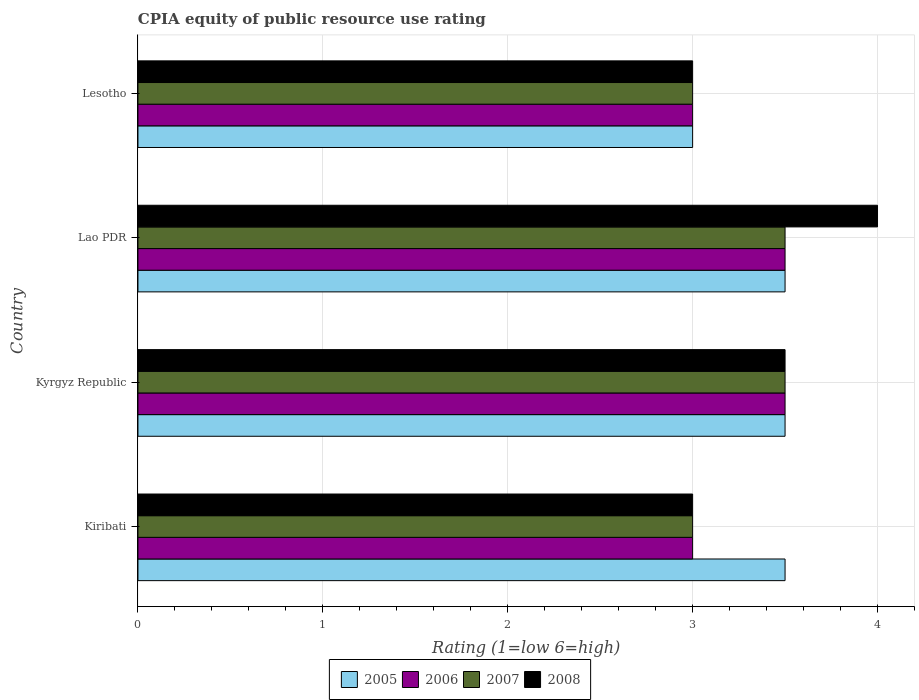How many different coloured bars are there?
Make the answer very short. 4. Are the number of bars per tick equal to the number of legend labels?
Your answer should be compact. Yes. How many bars are there on the 2nd tick from the top?
Give a very brief answer. 4. How many bars are there on the 4th tick from the bottom?
Keep it short and to the point. 4. What is the label of the 4th group of bars from the top?
Your answer should be compact. Kiribati. In how many cases, is the number of bars for a given country not equal to the number of legend labels?
Your answer should be compact. 0. What is the CPIA rating in 2005 in Lao PDR?
Provide a short and direct response. 3.5. Across all countries, what is the maximum CPIA rating in 2007?
Provide a short and direct response. 3.5. In which country was the CPIA rating in 2005 maximum?
Your response must be concise. Kiribati. In which country was the CPIA rating in 2005 minimum?
Your answer should be compact. Lesotho. What is the total CPIA rating in 2005 in the graph?
Ensure brevity in your answer.  13.5. What is the ratio of the CPIA rating in 2005 in Kyrgyz Republic to that in Lesotho?
Your answer should be compact. 1.17. What is the difference between the highest and the lowest CPIA rating in 2008?
Your answer should be compact. 1. Is the sum of the CPIA rating in 2006 in Kiribati and Kyrgyz Republic greater than the maximum CPIA rating in 2008 across all countries?
Your answer should be very brief. Yes. Is it the case that in every country, the sum of the CPIA rating in 2006 and CPIA rating in 2008 is greater than the sum of CPIA rating in 2007 and CPIA rating in 2005?
Your answer should be very brief. No. What does the 3rd bar from the bottom in Lao PDR represents?
Your response must be concise. 2007. How many bars are there?
Give a very brief answer. 16. Are all the bars in the graph horizontal?
Provide a short and direct response. Yes. What is the difference between two consecutive major ticks on the X-axis?
Your answer should be compact. 1. Are the values on the major ticks of X-axis written in scientific E-notation?
Your answer should be compact. No. Does the graph contain grids?
Give a very brief answer. Yes. How many legend labels are there?
Your answer should be very brief. 4. What is the title of the graph?
Offer a terse response. CPIA equity of public resource use rating. Does "1985" appear as one of the legend labels in the graph?
Provide a succinct answer. No. What is the label or title of the X-axis?
Ensure brevity in your answer.  Rating (1=low 6=high). What is the label or title of the Y-axis?
Offer a very short reply. Country. What is the Rating (1=low 6=high) of 2006 in Kiribati?
Your answer should be very brief. 3. What is the Rating (1=low 6=high) of 2008 in Kiribati?
Offer a terse response. 3. What is the Rating (1=low 6=high) in 2006 in Kyrgyz Republic?
Provide a short and direct response. 3.5. What is the Rating (1=low 6=high) in 2007 in Kyrgyz Republic?
Your answer should be very brief. 3.5. What is the Rating (1=low 6=high) in 2008 in Kyrgyz Republic?
Your response must be concise. 3.5. What is the Rating (1=low 6=high) of 2006 in Lao PDR?
Keep it short and to the point. 3.5. What is the Rating (1=low 6=high) of 2006 in Lesotho?
Offer a very short reply. 3. What is the Rating (1=low 6=high) in 2007 in Lesotho?
Give a very brief answer. 3. Across all countries, what is the maximum Rating (1=low 6=high) in 2007?
Your answer should be compact. 3.5. Across all countries, what is the maximum Rating (1=low 6=high) of 2008?
Make the answer very short. 4. Across all countries, what is the minimum Rating (1=low 6=high) in 2005?
Offer a terse response. 3. Across all countries, what is the minimum Rating (1=low 6=high) of 2006?
Provide a succinct answer. 3. Across all countries, what is the minimum Rating (1=low 6=high) in 2008?
Keep it short and to the point. 3. What is the total Rating (1=low 6=high) in 2005 in the graph?
Offer a very short reply. 13.5. What is the total Rating (1=low 6=high) in 2006 in the graph?
Make the answer very short. 13. What is the total Rating (1=low 6=high) in 2007 in the graph?
Offer a terse response. 13. What is the difference between the Rating (1=low 6=high) of 2005 in Kiribati and that in Kyrgyz Republic?
Give a very brief answer. 0. What is the difference between the Rating (1=low 6=high) in 2007 in Kiribati and that in Kyrgyz Republic?
Provide a short and direct response. -0.5. What is the difference between the Rating (1=low 6=high) of 2008 in Kiribati and that in Kyrgyz Republic?
Your response must be concise. -0.5. What is the difference between the Rating (1=low 6=high) of 2005 in Kiribati and that in Lao PDR?
Give a very brief answer. 0. What is the difference between the Rating (1=low 6=high) of 2006 in Kiribati and that in Lao PDR?
Provide a succinct answer. -0.5. What is the difference between the Rating (1=low 6=high) of 2007 in Kiribati and that in Lao PDR?
Offer a terse response. -0.5. What is the difference between the Rating (1=low 6=high) of 2008 in Kiribati and that in Lao PDR?
Provide a short and direct response. -1. What is the difference between the Rating (1=low 6=high) in 2005 in Kiribati and that in Lesotho?
Provide a succinct answer. 0.5. What is the difference between the Rating (1=low 6=high) of 2006 in Kiribati and that in Lesotho?
Your answer should be very brief. 0. What is the difference between the Rating (1=low 6=high) of 2007 in Kiribati and that in Lesotho?
Ensure brevity in your answer.  0. What is the difference between the Rating (1=low 6=high) of 2007 in Kyrgyz Republic and that in Lao PDR?
Ensure brevity in your answer.  0. What is the difference between the Rating (1=low 6=high) of 2005 in Kyrgyz Republic and that in Lesotho?
Your response must be concise. 0.5. What is the difference between the Rating (1=low 6=high) in 2006 in Kyrgyz Republic and that in Lesotho?
Provide a short and direct response. 0.5. What is the difference between the Rating (1=low 6=high) of 2007 in Kyrgyz Republic and that in Lesotho?
Provide a succinct answer. 0.5. What is the difference between the Rating (1=low 6=high) in 2008 in Kyrgyz Republic and that in Lesotho?
Provide a succinct answer. 0.5. What is the difference between the Rating (1=low 6=high) in 2005 in Lao PDR and that in Lesotho?
Ensure brevity in your answer.  0.5. What is the difference between the Rating (1=low 6=high) of 2008 in Lao PDR and that in Lesotho?
Provide a succinct answer. 1. What is the difference between the Rating (1=low 6=high) of 2005 in Kiribati and the Rating (1=low 6=high) of 2007 in Kyrgyz Republic?
Offer a terse response. 0. What is the difference between the Rating (1=low 6=high) of 2006 in Kiribati and the Rating (1=low 6=high) of 2007 in Kyrgyz Republic?
Offer a terse response. -0.5. What is the difference between the Rating (1=low 6=high) of 2005 in Kiribati and the Rating (1=low 6=high) of 2008 in Lao PDR?
Give a very brief answer. -0.5. What is the difference between the Rating (1=low 6=high) of 2007 in Kiribati and the Rating (1=low 6=high) of 2008 in Lao PDR?
Offer a very short reply. -1. What is the difference between the Rating (1=low 6=high) of 2005 in Kiribati and the Rating (1=low 6=high) of 2007 in Lesotho?
Your answer should be compact. 0.5. What is the difference between the Rating (1=low 6=high) of 2005 in Kiribati and the Rating (1=low 6=high) of 2008 in Lesotho?
Provide a short and direct response. 0.5. What is the difference between the Rating (1=low 6=high) of 2006 in Kiribati and the Rating (1=low 6=high) of 2007 in Lesotho?
Give a very brief answer. 0. What is the difference between the Rating (1=low 6=high) in 2005 in Kyrgyz Republic and the Rating (1=low 6=high) in 2008 in Lao PDR?
Your answer should be compact. -0.5. What is the difference between the Rating (1=low 6=high) in 2006 in Kyrgyz Republic and the Rating (1=low 6=high) in 2007 in Lao PDR?
Offer a very short reply. 0. What is the difference between the Rating (1=low 6=high) in 2006 in Kyrgyz Republic and the Rating (1=low 6=high) in 2008 in Lao PDR?
Make the answer very short. -0.5. What is the difference between the Rating (1=low 6=high) in 2005 in Kyrgyz Republic and the Rating (1=low 6=high) in 2007 in Lesotho?
Your answer should be compact. 0.5. What is the difference between the Rating (1=low 6=high) in 2006 in Kyrgyz Republic and the Rating (1=low 6=high) in 2007 in Lesotho?
Provide a short and direct response. 0.5. What is the difference between the Rating (1=low 6=high) in 2006 in Kyrgyz Republic and the Rating (1=low 6=high) in 2008 in Lesotho?
Keep it short and to the point. 0.5. What is the difference between the Rating (1=low 6=high) in 2007 in Kyrgyz Republic and the Rating (1=low 6=high) in 2008 in Lesotho?
Your response must be concise. 0.5. What is the difference between the Rating (1=low 6=high) of 2005 in Lao PDR and the Rating (1=low 6=high) of 2006 in Lesotho?
Your response must be concise. 0.5. What is the difference between the Rating (1=low 6=high) in 2006 in Lao PDR and the Rating (1=low 6=high) in 2008 in Lesotho?
Provide a succinct answer. 0.5. What is the average Rating (1=low 6=high) of 2005 per country?
Offer a very short reply. 3.38. What is the average Rating (1=low 6=high) in 2007 per country?
Offer a very short reply. 3.25. What is the average Rating (1=low 6=high) in 2008 per country?
Offer a terse response. 3.38. What is the difference between the Rating (1=low 6=high) in 2005 and Rating (1=low 6=high) in 2006 in Kiribati?
Offer a terse response. 0.5. What is the difference between the Rating (1=low 6=high) of 2005 and Rating (1=low 6=high) of 2007 in Kiribati?
Your answer should be very brief. 0.5. What is the difference between the Rating (1=low 6=high) of 2006 and Rating (1=low 6=high) of 2007 in Kiribati?
Make the answer very short. 0. What is the difference between the Rating (1=low 6=high) in 2005 and Rating (1=low 6=high) in 2007 in Kyrgyz Republic?
Provide a succinct answer. 0. What is the difference between the Rating (1=low 6=high) of 2006 and Rating (1=low 6=high) of 2007 in Kyrgyz Republic?
Offer a terse response. 0. What is the difference between the Rating (1=low 6=high) in 2006 and Rating (1=low 6=high) in 2008 in Lao PDR?
Your answer should be very brief. -0.5. What is the difference between the Rating (1=low 6=high) in 2007 and Rating (1=low 6=high) in 2008 in Lao PDR?
Your answer should be very brief. -0.5. What is the difference between the Rating (1=low 6=high) of 2005 and Rating (1=low 6=high) of 2006 in Lesotho?
Offer a terse response. 0. What is the difference between the Rating (1=low 6=high) in 2006 and Rating (1=low 6=high) in 2007 in Lesotho?
Provide a succinct answer. 0. What is the difference between the Rating (1=low 6=high) of 2007 and Rating (1=low 6=high) of 2008 in Lesotho?
Your answer should be very brief. 0. What is the ratio of the Rating (1=low 6=high) of 2005 in Kiribati to that in Kyrgyz Republic?
Offer a terse response. 1. What is the ratio of the Rating (1=low 6=high) of 2008 in Kiribati to that in Kyrgyz Republic?
Your answer should be very brief. 0.86. What is the ratio of the Rating (1=low 6=high) of 2005 in Kiribati to that in Lao PDR?
Make the answer very short. 1. What is the ratio of the Rating (1=low 6=high) in 2006 in Kiribati to that in Lao PDR?
Offer a terse response. 0.86. What is the ratio of the Rating (1=low 6=high) in 2007 in Kiribati to that in Lao PDR?
Your answer should be compact. 0.86. What is the ratio of the Rating (1=low 6=high) in 2008 in Kiribati to that in Lao PDR?
Offer a very short reply. 0.75. What is the ratio of the Rating (1=low 6=high) in 2007 in Kiribati to that in Lesotho?
Provide a succinct answer. 1. What is the ratio of the Rating (1=low 6=high) in 2008 in Kiribati to that in Lesotho?
Make the answer very short. 1. What is the ratio of the Rating (1=low 6=high) in 2007 in Kyrgyz Republic to that in Lao PDR?
Your answer should be compact. 1. What is the ratio of the Rating (1=low 6=high) of 2008 in Kyrgyz Republic to that in Lao PDR?
Provide a short and direct response. 0.88. What is the ratio of the Rating (1=low 6=high) of 2005 in Kyrgyz Republic to that in Lesotho?
Your response must be concise. 1.17. What is the ratio of the Rating (1=low 6=high) in 2007 in Lao PDR to that in Lesotho?
Make the answer very short. 1.17. What is the ratio of the Rating (1=low 6=high) in 2008 in Lao PDR to that in Lesotho?
Provide a short and direct response. 1.33. What is the difference between the highest and the second highest Rating (1=low 6=high) of 2007?
Your response must be concise. 0. What is the difference between the highest and the lowest Rating (1=low 6=high) of 2006?
Your answer should be compact. 0.5. 